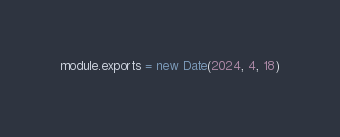Convert code to text. <code><loc_0><loc_0><loc_500><loc_500><_JavaScript_>module.exports = new Date(2024, 4, 18)
</code> 